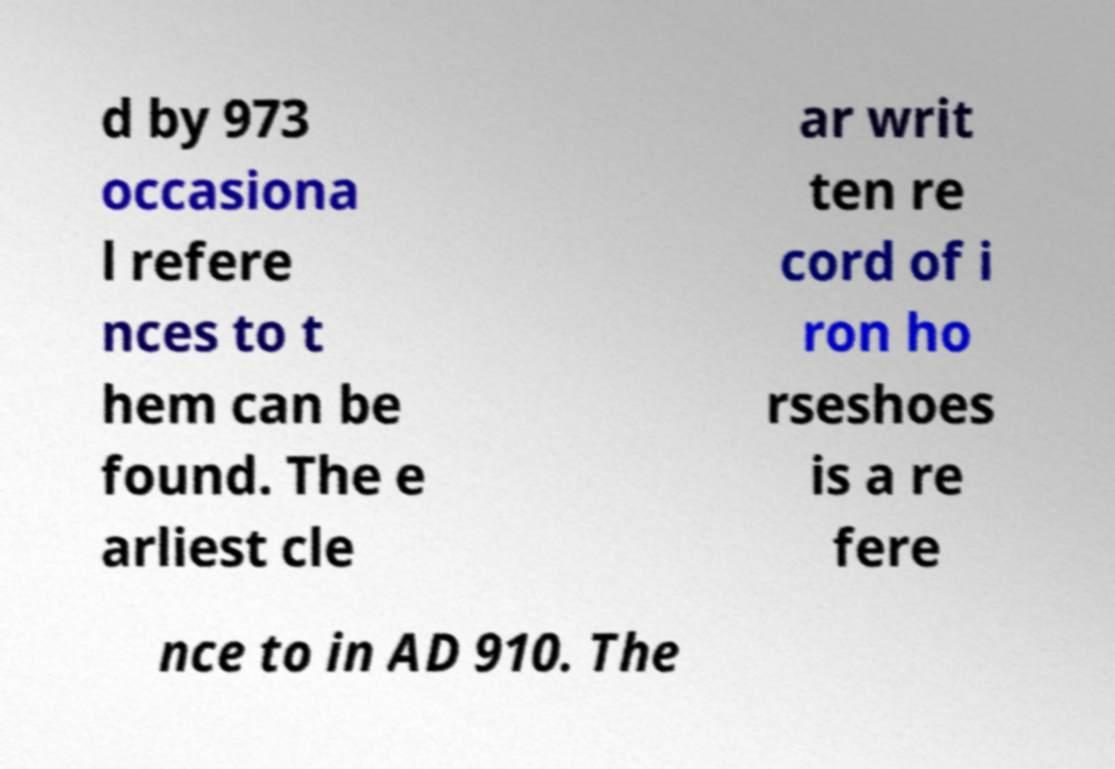I need the written content from this picture converted into text. Can you do that? d by 973 occasiona l refere nces to t hem can be found. The e arliest cle ar writ ten re cord of i ron ho rseshoes is a re fere nce to in AD 910. The 